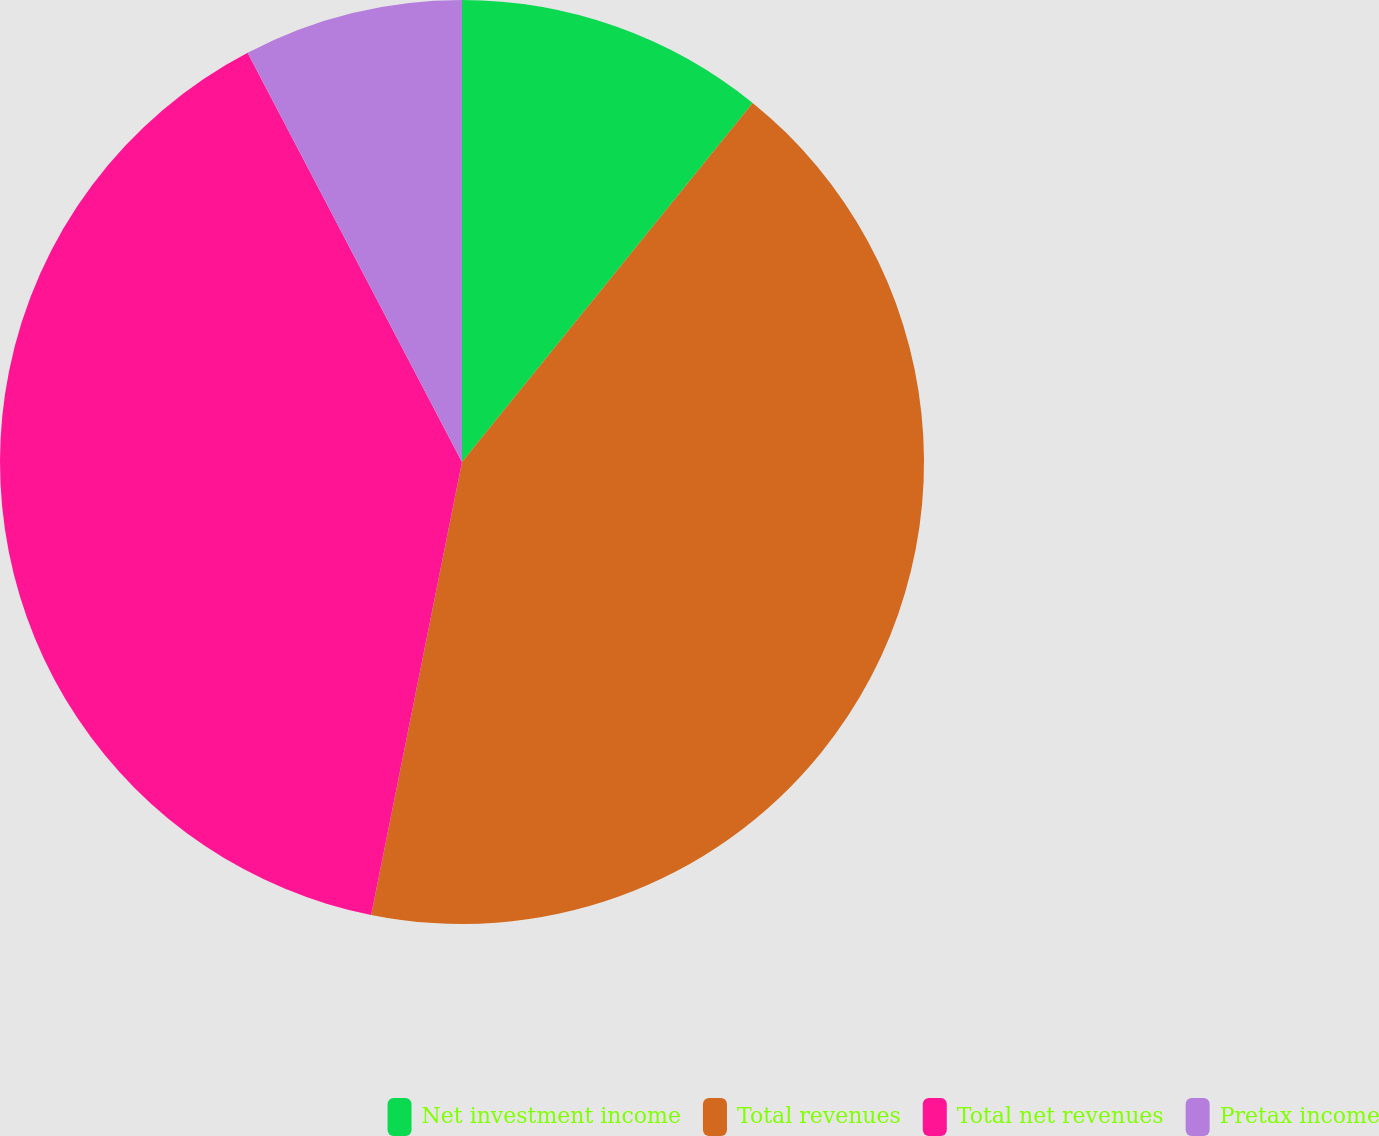Convert chart to OTSL. <chart><loc_0><loc_0><loc_500><loc_500><pie_chart><fcel>Net investment income<fcel>Total revenues<fcel>Total net revenues<fcel>Pretax income<nl><fcel>10.83%<fcel>42.32%<fcel>39.17%<fcel>7.68%<nl></chart> 